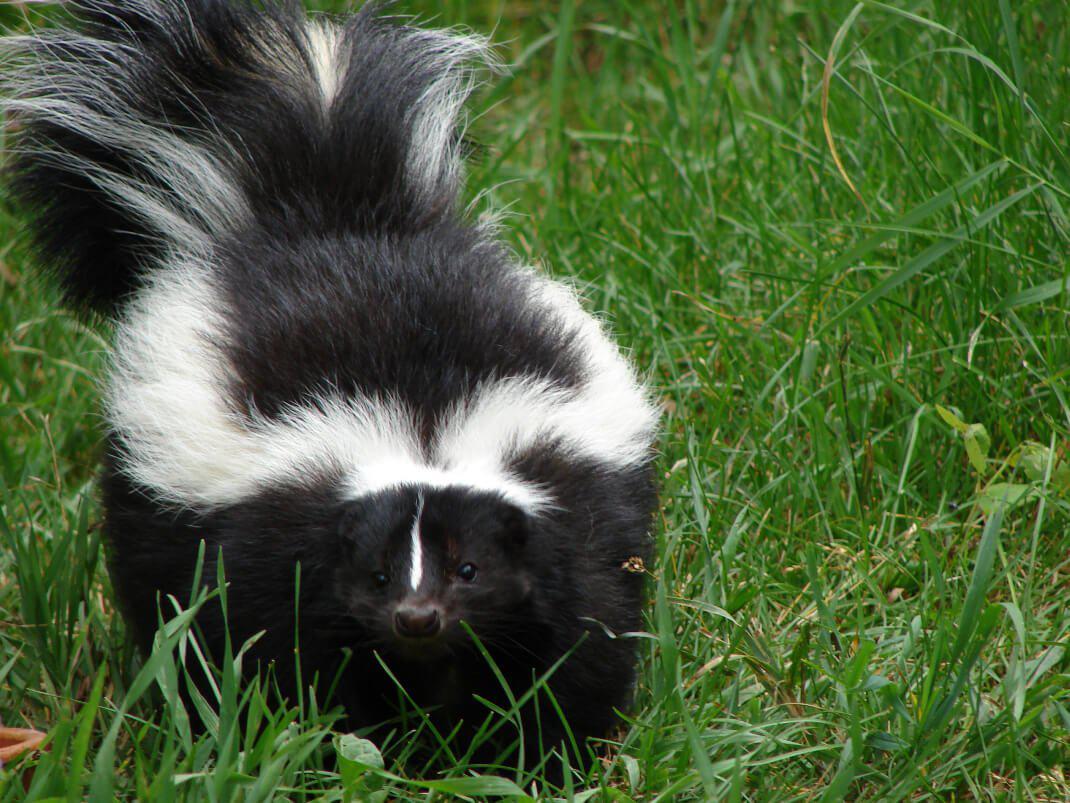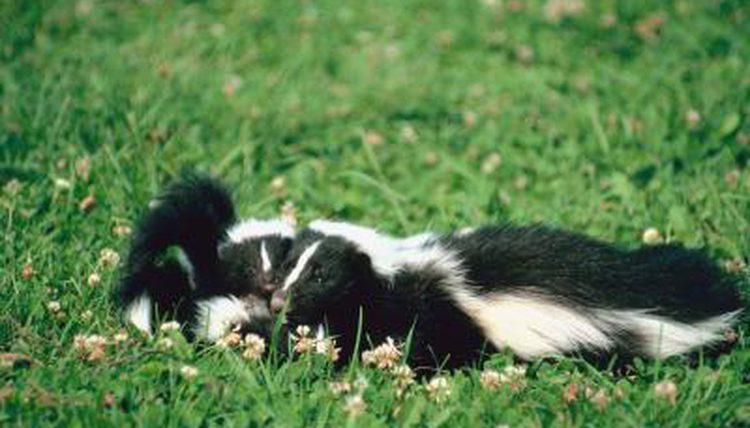The first image is the image on the left, the second image is the image on the right. Given the left and right images, does the statement "There is a single skunk in the right image." hold true? Answer yes or no. No. 